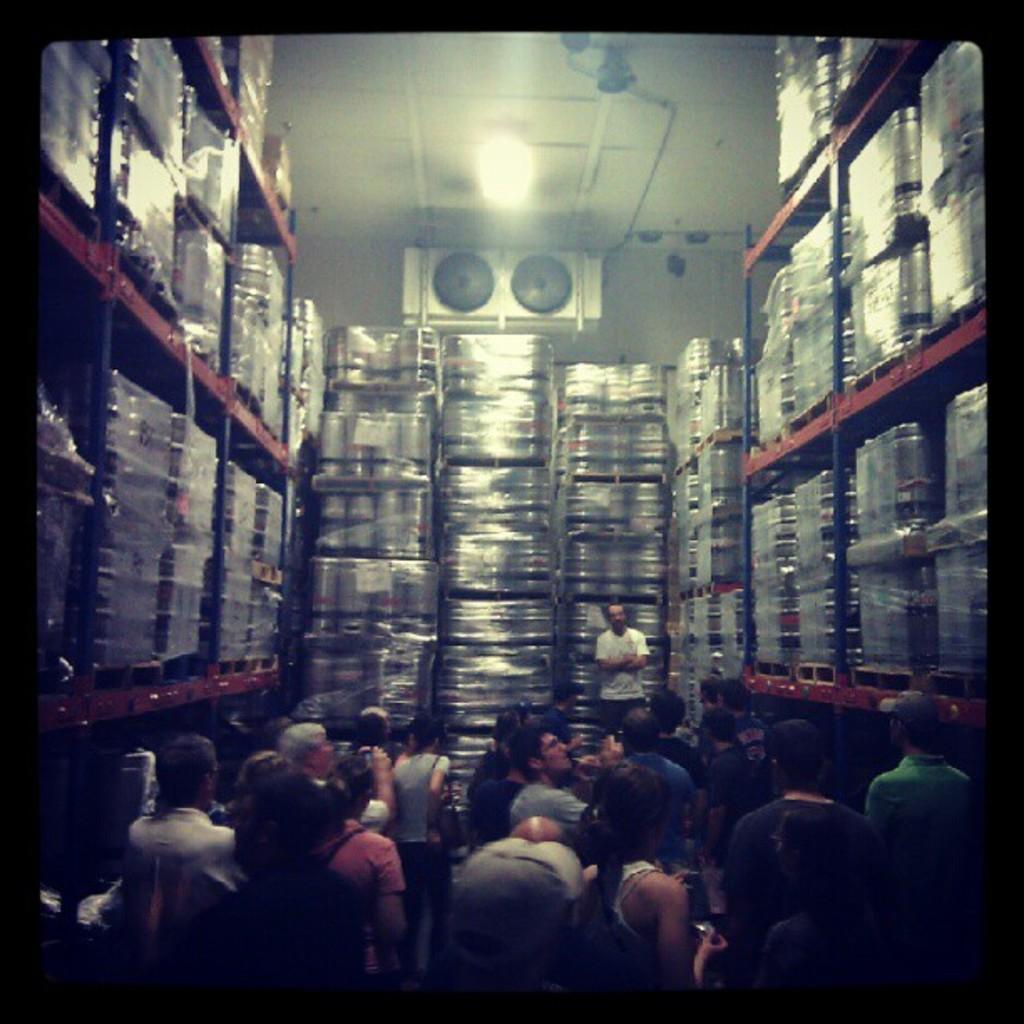What type of objects are stored in the racks in the image? There are steel objects in the racks in the image. Who or what can be seen at the bottom of the image? There are persons at the bottom of the image. What is visible at the top of the image? The ceiling is visible at the top of the image, along with lights and other objects. What type of nut is hanging from the ceiling in the image? There is no nut hanging from the ceiling in the image. What historical event is depicted in the image? There is no historical event depicted in the image; it features steel objects in racks, persons at the bottom, and a ceiling with lights and other objects at the top. 